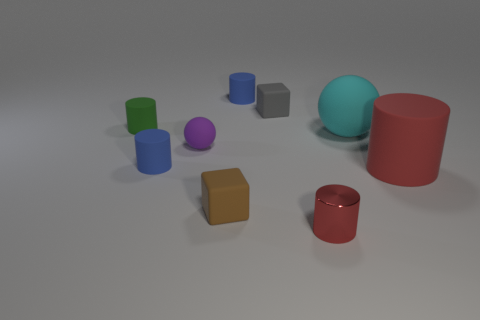There is a tiny red metallic thing on the left side of the big cyan rubber sphere; is it the same shape as the large cyan thing?
Your response must be concise. No. Are there any brown rubber objects in front of the tiny brown rubber block?
Provide a short and direct response. No. What number of small things are gray things or cyan balls?
Your answer should be compact. 1. Do the small brown object and the small green thing have the same material?
Make the answer very short. Yes. There is another object that is the same color as the small metal object; what size is it?
Offer a very short reply. Large. Are there any cubes that have the same color as the big cylinder?
Provide a succinct answer. No. There is a cyan object that is the same material as the gray block; what is its size?
Your answer should be compact. Large. There is a red thing that is on the right side of the cyan matte ball in front of the small rubber block behind the large ball; what shape is it?
Your response must be concise. Cylinder. What is the size of the other red thing that is the same shape as the large red thing?
Give a very brief answer. Small. What size is the object that is both to the left of the tiny matte sphere and in front of the green thing?
Make the answer very short. Small. 